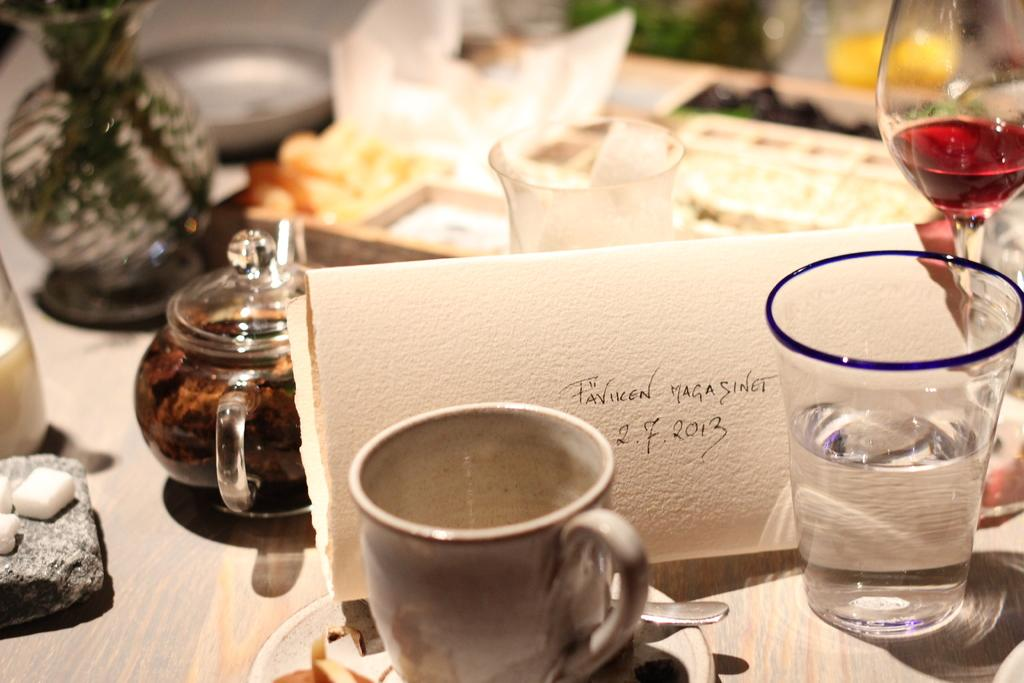What types of containers are visible in the image? There are cups and glasses in the image. Can you describe any other objects present in the image? There are other objects in the image, but their specific details are not mentioned in the provided facts. How does the crate balance on the edge of the table in the image? There is no crate present in the image, so it cannot be balanced on the edge of the table. 